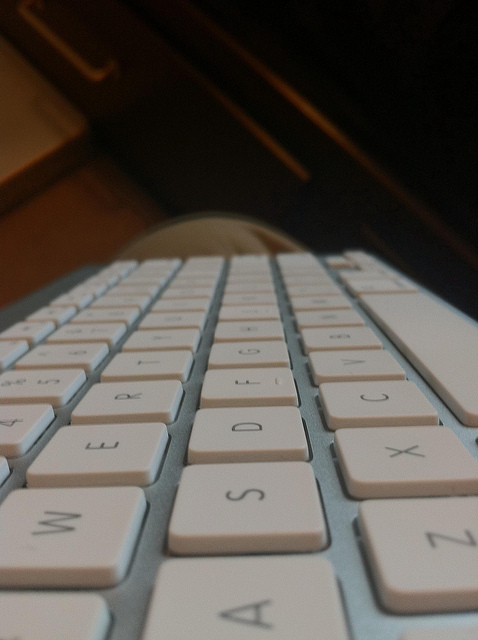<image>What side of the keyboard is the camera? I am not sure what side of the keyboard the camera is on. It may be on the left or right side. What side of the keyboard is the camera? I don't know what side of the keyboard the camera is. It can be on the left or right side. 